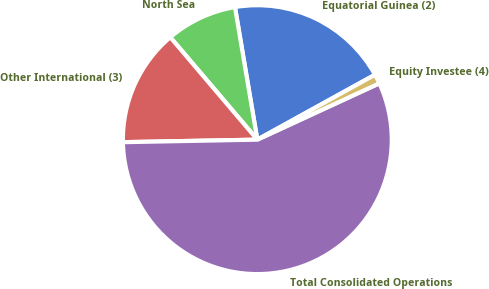Convert chart to OTSL. <chart><loc_0><loc_0><loc_500><loc_500><pie_chart><fcel>Equatorial Guinea (2)<fcel>North Sea<fcel>Other International (3)<fcel>Total Consolidated Operations<fcel>Equity Investee (4)<nl><fcel>19.64%<fcel>8.55%<fcel>14.09%<fcel>56.59%<fcel>1.14%<nl></chart> 